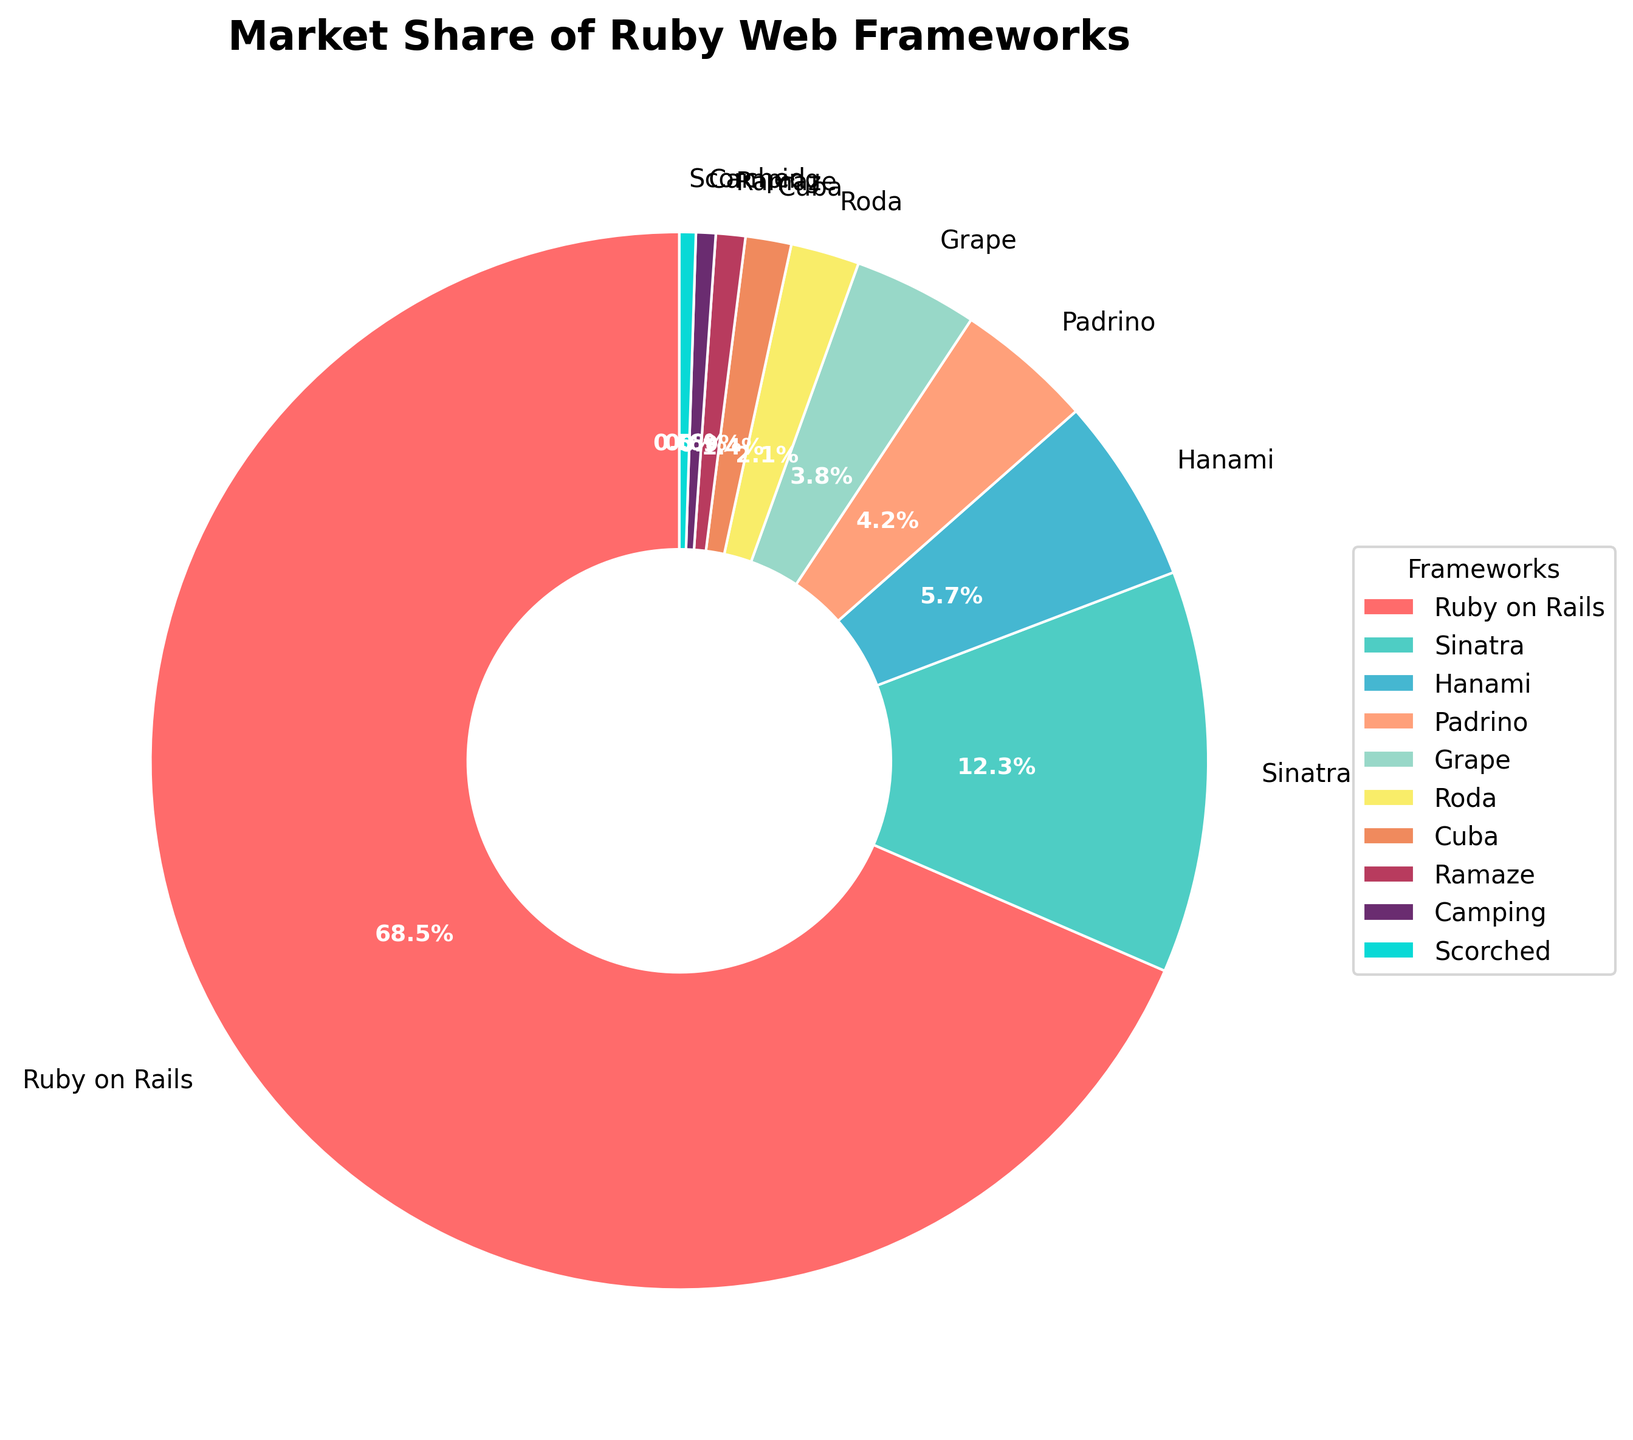Which framework has the largest market share? The pie chart shows that "Ruby on Rails" occupies the largest portion of the pie with a market share of 68.5%.
Answer: Ruby on Rails What is the combined market share of Sinatra and Hanami? To find the combined market share, add the percentages of Sinatra (12.3%) and Hanami (5.7%). Therefore, it is 12.3 + 5.7 = 18%.
Answer: 18% By how much does the market share of Padrino exceed that of Roda? The market share of Padrino is 4.2%, and that of Roda is 2.1%. The difference is calculated by subtracting Roda's share from Padrino's share: 4.2 - 2.1 = 2.1%.
Answer: 2.1% Which two frameworks have the smallest market shares, and what are their combined market shares? The two smallest slices in the pie chart belong to Scorched (0.5%) and Camping (0.6%). Their combined market share is 0.5 + 0.6 = 1.1%.
Answer: Scorched and Camping; 1.1% How does the market share of Grape compare to the combined share of Roda and Cuba? Grape has a market share of 3.8%. The combined share of Roda (2.1%) and Cuba (1.4%) is 2.1 + 1.4 = 3.5%. Since 3.8% is greater than 3.5%, Grape has a larger market share.
Answer: Grape is greater What is the aggregate market share of the frameworks with less than 5% each? Identify the frameworks under 5%: Hanami (5.7%) is excluded. Padrino (4.2%), Grape (3.8%), Roda (2.1%), Cuba (1.4%), Ramaze (0.9%), Camping (0.6%), and Scorched (0.5%) are included. Sum their shares: 4.2 + 3.8 + 2.1 + 1.4 + 0.9 + 0.6 + 0.5 = 13.5%.
Answer: 13.5% Among the frameworks with at least 10% share, which ones are they? Only two frameworks have at least 10% market share: Ruby on Rails (68.5%) and Sinatra (12.3%).
Answer: Ruby on Rails and Sinatra Which framework is represented by a reddish color in the pie chart, and what is its market share? The pie chart indicates that Ruby on Rails is represented by a reddish color and has the largest portion of the chart with a market share of 68.5%.
Answer: Ruby on Rails; 68.5% What percentage of the market share is occupied by frameworks with a market share greater than 10%? Frameworks greater than 10% are Ruby on Rails (68.5%) and Sinatra (12.3%). Their combined market share is 68.5 + 12.3 = 80.8%.
Answer: 80.8% Which framework has a market share closest to 2%, and what is its exact percentage? The framework closest to 2% is Roda with a market share of 2.1%.
Answer: Roda; 2.1% 